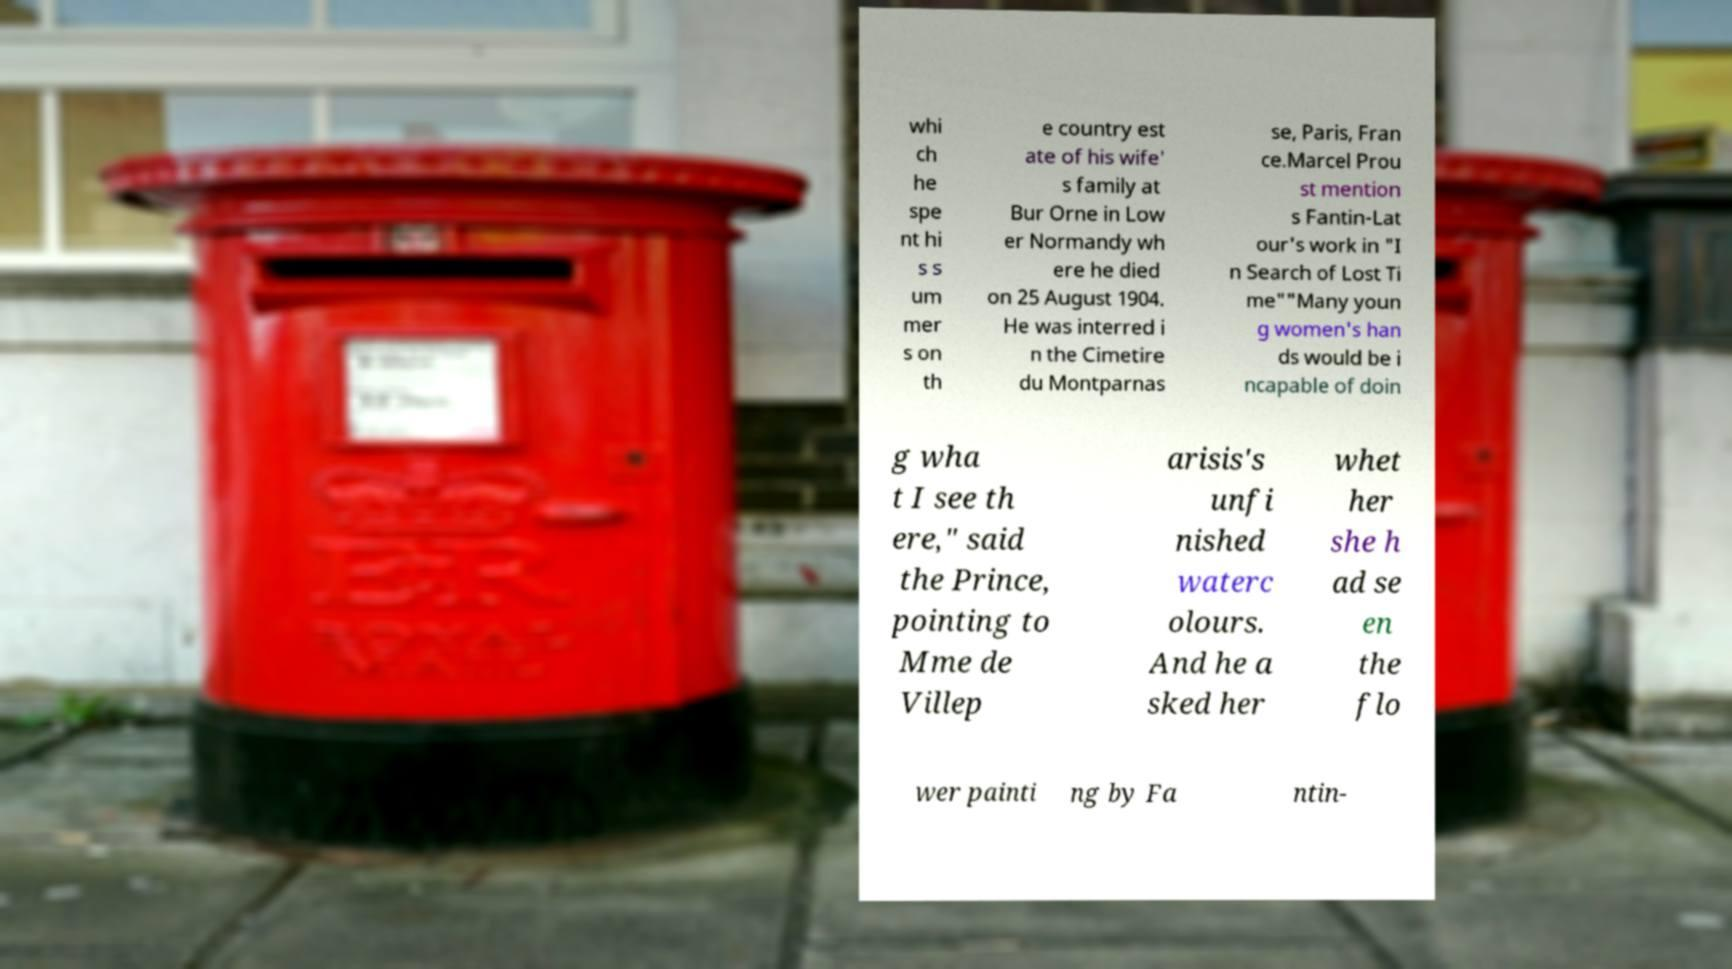Could you extract and type out the text from this image? whi ch he spe nt hi s s um mer s on th e country est ate of his wife' s family at Bur Orne in Low er Normandy wh ere he died on 25 August 1904. He was interred i n the Cimetire du Montparnas se, Paris, Fran ce.Marcel Prou st mention s Fantin-Lat our's work in "I n Search of Lost Ti me""Many youn g women's han ds would be i ncapable of doin g wha t I see th ere," said the Prince, pointing to Mme de Villep arisis's unfi nished waterc olours. And he a sked her whet her she h ad se en the flo wer painti ng by Fa ntin- 